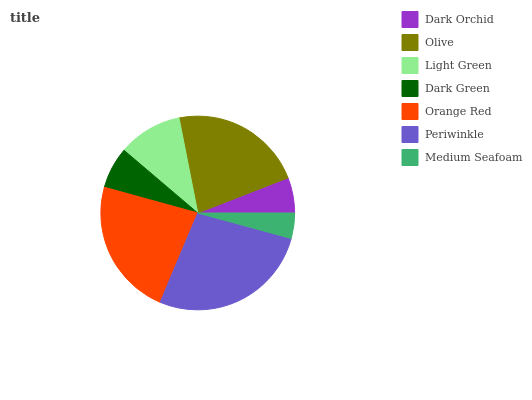Is Medium Seafoam the minimum?
Answer yes or no. Yes. Is Periwinkle the maximum?
Answer yes or no. Yes. Is Olive the minimum?
Answer yes or no. No. Is Olive the maximum?
Answer yes or no. No. Is Olive greater than Dark Orchid?
Answer yes or no. Yes. Is Dark Orchid less than Olive?
Answer yes or no. Yes. Is Dark Orchid greater than Olive?
Answer yes or no. No. Is Olive less than Dark Orchid?
Answer yes or no. No. Is Light Green the high median?
Answer yes or no. Yes. Is Light Green the low median?
Answer yes or no. Yes. Is Periwinkle the high median?
Answer yes or no. No. Is Dark Orchid the low median?
Answer yes or no. No. 